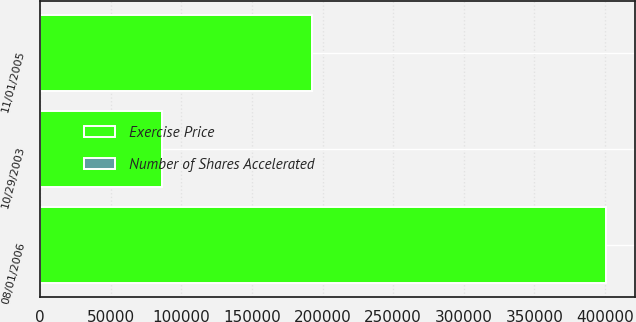Convert chart to OTSL. <chart><loc_0><loc_0><loc_500><loc_500><stacked_bar_chart><ecel><fcel>10/29/2003<fcel>11/01/2005<fcel>08/01/2006<nl><fcel>Number of Shares Accelerated<fcel>15.87<fcel>23.46<fcel>17.94<nl><fcel>Exercise Price<fcel>86340<fcel>192650<fcel>400813<nl></chart> 